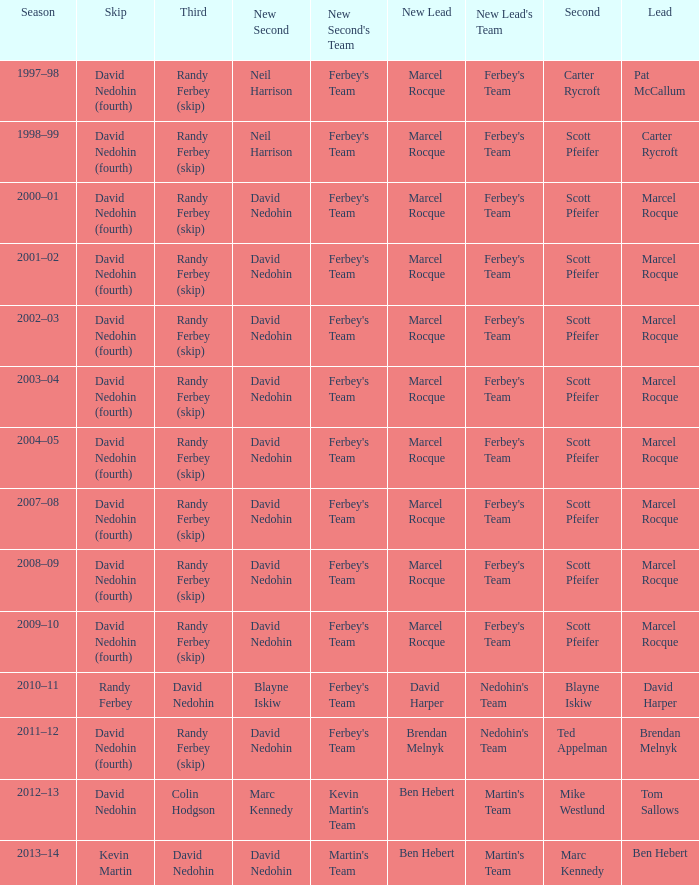Which Third has a Second of scott pfeifer? Randy Ferbey (skip), Randy Ferbey (skip), Randy Ferbey (skip), Randy Ferbey (skip), Randy Ferbey (skip), Randy Ferbey (skip), Randy Ferbey (skip), Randy Ferbey (skip), Randy Ferbey (skip). 